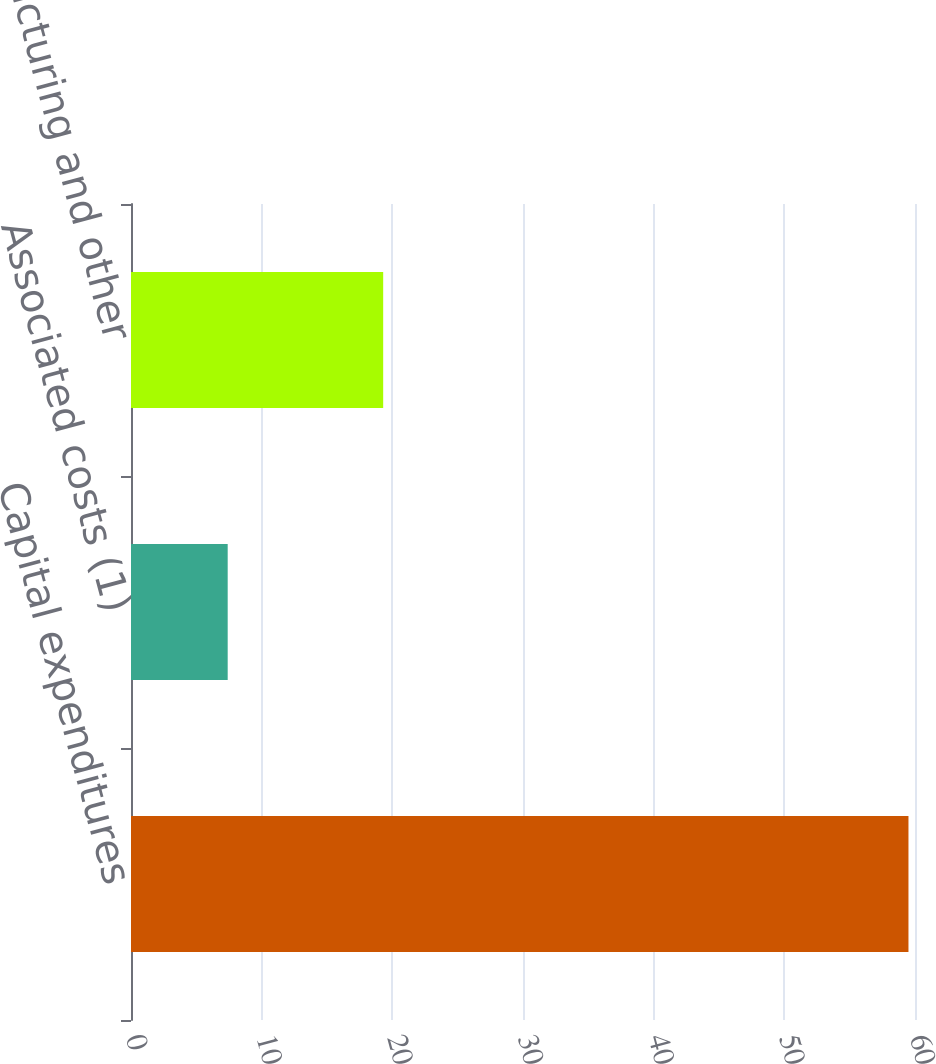Convert chart. <chart><loc_0><loc_0><loc_500><loc_500><bar_chart><fcel>Capital expenditures<fcel>Associated costs (1)<fcel>Restructuring and other<nl><fcel>59.5<fcel>7.4<fcel>19.3<nl></chart> 